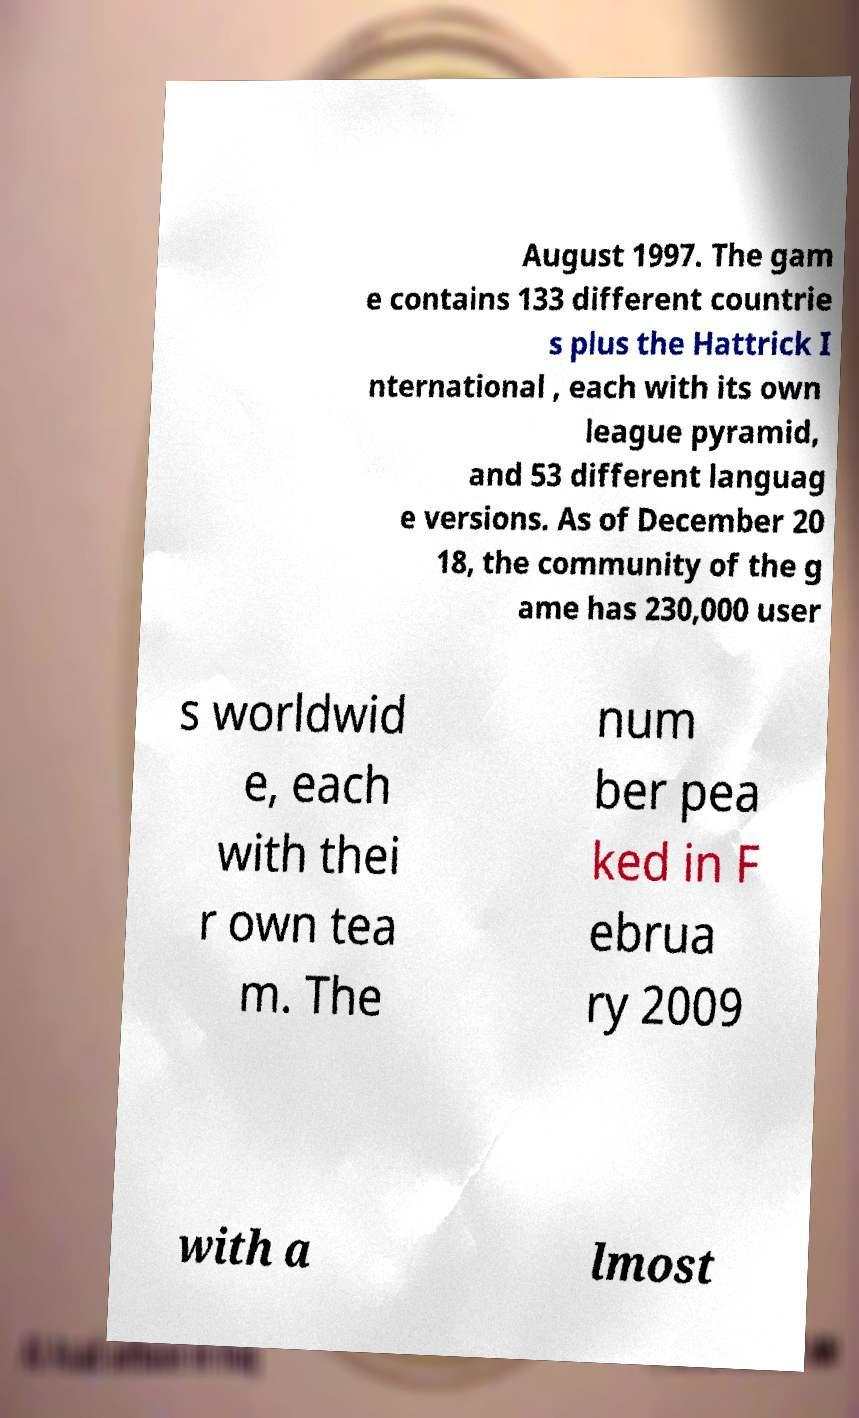I need the written content from this picture converted into text. Can you do that? August 1997. The gam e contains 133 different countrie s plus the Hattrick I nternational , each with its own league pyramid, and 53 different languag e versions. As of December 20 18, the community of the g ame has 230,000 user s worldwid e, each with thei r own tea m. The num ber pea ked in F ebrua ry 2009 with a lmost 